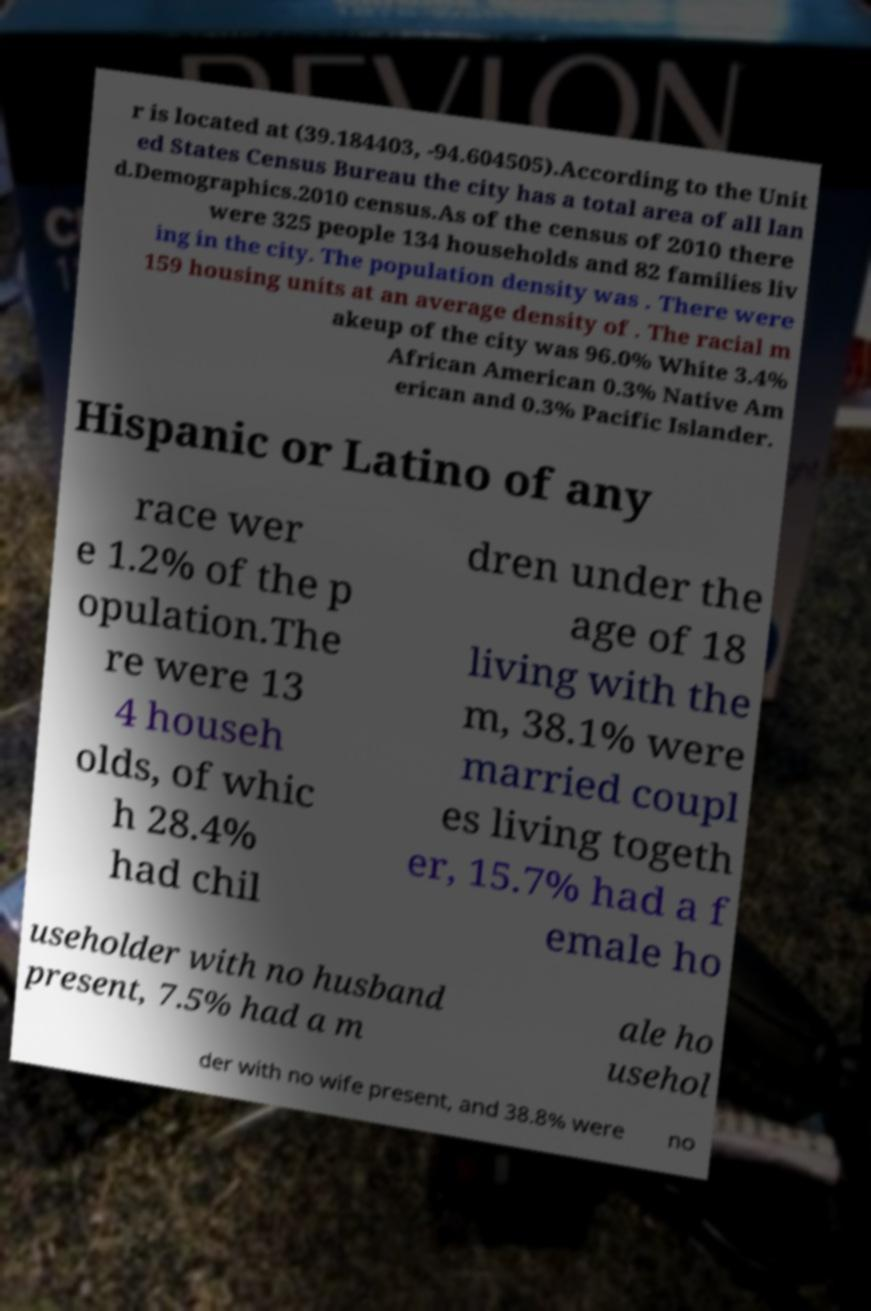Can you accurately transcribe the text from the provided image for me? r is located at (39.184403, -94.604505).According to the Unit ed States Census Bureau the city has a total area of all lan d.Demographics.2010 census.As of the census of 2010 there were 325 people 134 households and 82 families liv ing in the city. The population density was . There were 159 housing units at an average density of . The racial m akeup of the city was 96.0% White 3.4% African American 0.3% Native Am erican and 0.3% Pacific Islander. Hispanic or Latino of any race wer e 1.2% of the p opulation.The re were 13 4 househ olds, of whic h 28.4% had chil dren under the age of 18 living with the m, 38.1% were married coupl es living togeth er, 15.7% had a f emale ho useholder with no husband present, 7.5% had a m ale ho usehol der with no wife present, and 38.8% were no 